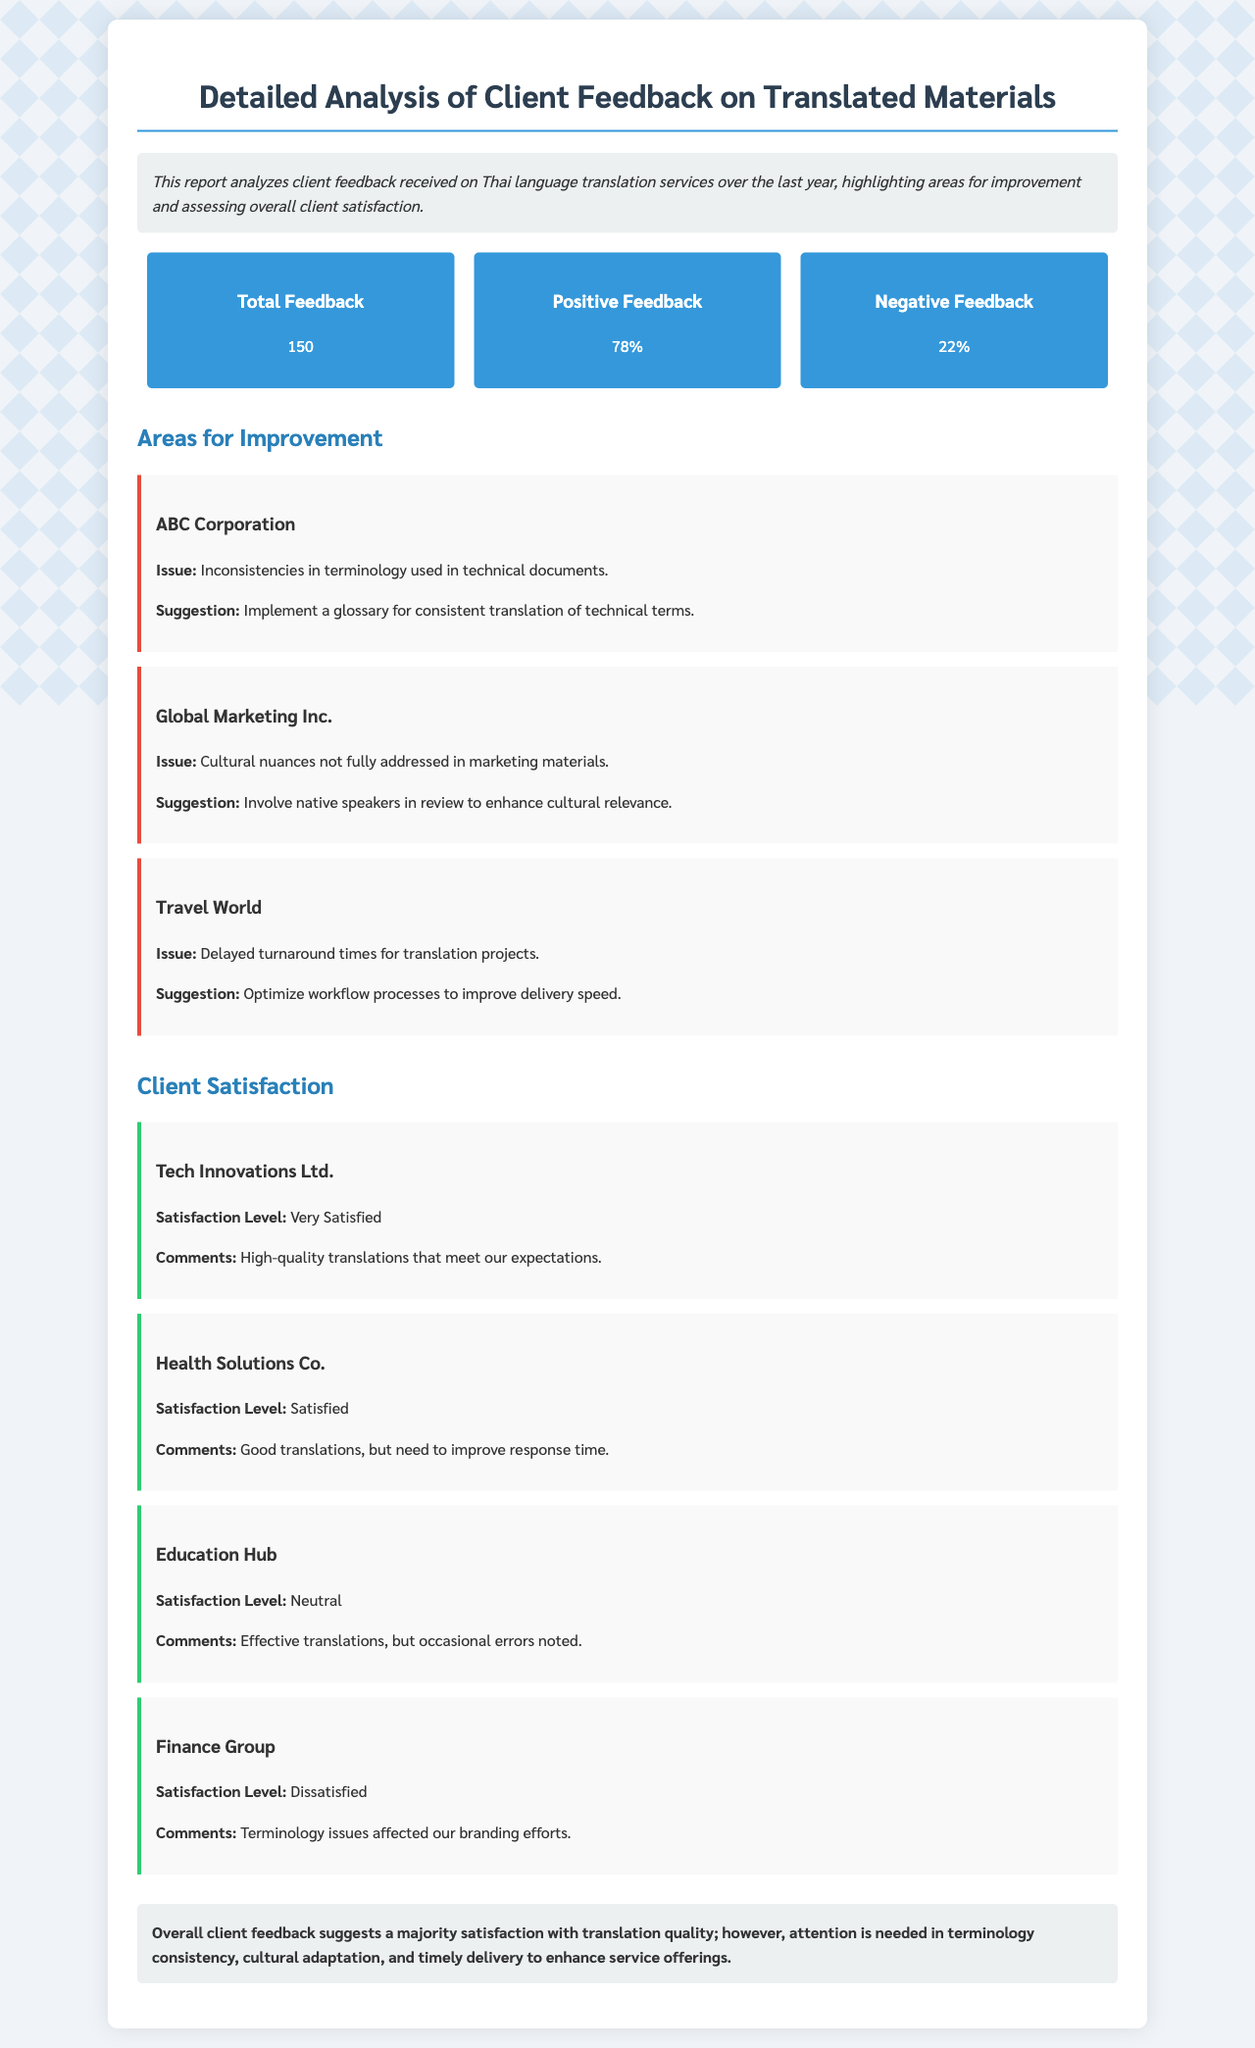What is the total feedback received? The document states that the total feedback received concerning Thai translation services is 150.
Answer: 150 What percentage of feedback was positive? The positive feedback percentage is explicitly stated in the document as 78%.
Answer: 78% What is the main issue faced by ABC Corporation? The document lists that ABC Corporation experienced inconsistencies in terminology used in technical documents.
Answer: Inconsistencies in terminology What suggestion is given for improving cultural nuances in Global Marketing Inc.? The document suggests involving native speakers in review to enhance cultural relevance when addressing cultural nuances.
Answer: Involve native speakers Which client expressed being Very Satisfied with the service? Tech Innovations Ltd. is mentioned in the document as a client that is Very Satisfied.
Answer: Tech Innovations Ltd What was the satisfaction level of Finance Group? The document specifies that Finance Group's satisfaction level is categorized as Dissatisfied.
Answer: Dissatisfied Which area needs improvement in terms of translation project turnaround? The document mentions that Travel World indicated delayed turnaround times for translation projects as an area needing improvement.
Answer: Delayed turnaround times How many clients expressed neutral satisfaction? The document notes that Education Hub expressed a Neutral satisfaction level regarding the translation services.
Answer: 1 What is one improvement suggested for feedback from Health Solutions Co.? The document states that Health Solutions Co. needs to improve their response time based on client comments.
Answer: Improve response time 